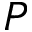<formula> <loc_0><loc_0><loc_500><loc_500>P</formula> 